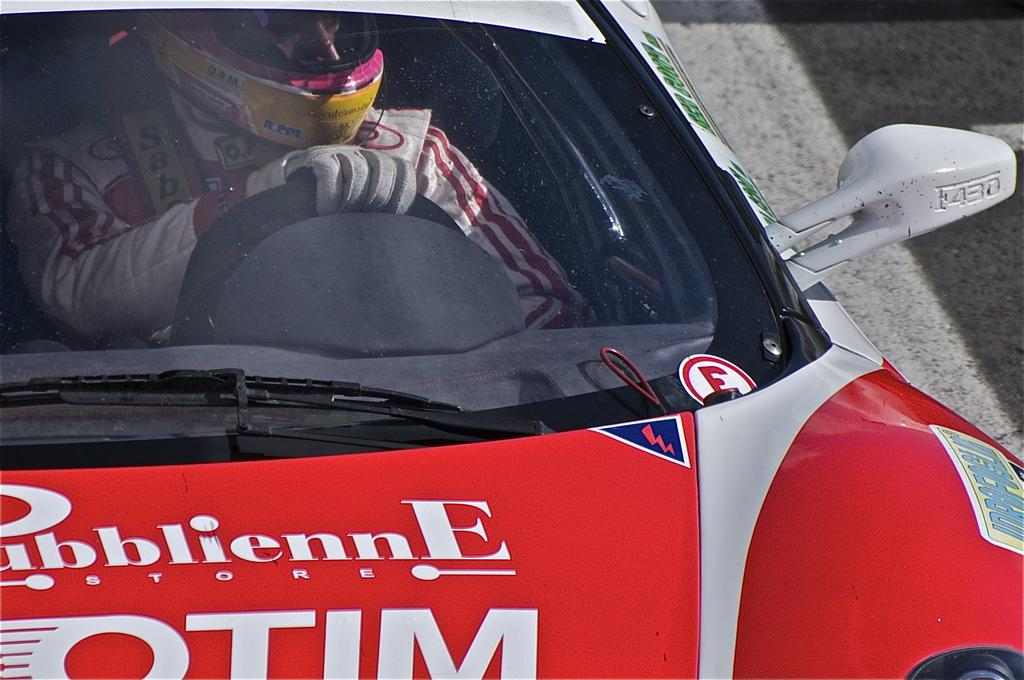What is inside the vehicle in the image? There is a person inside the vehicle. How is the vehicle positioned in the image? The vehicle is on the ground. What type of grape is being transported by the person inside the vehicle? There is no grape present in the image, and the person inside the vehicle is not transporting any grapes. Is the person inside the vehicle sleeping? There is no indication in the image that the person inside the vehicle is sleeping. 